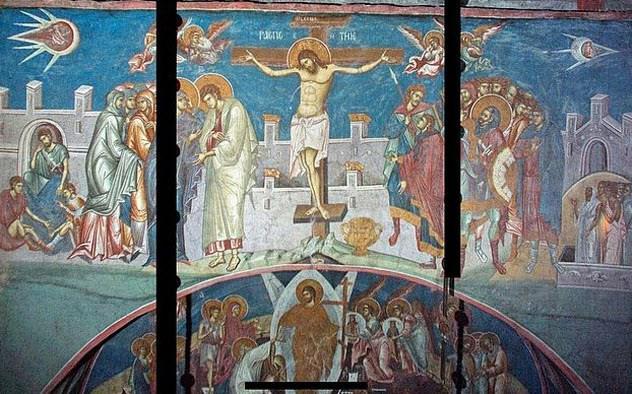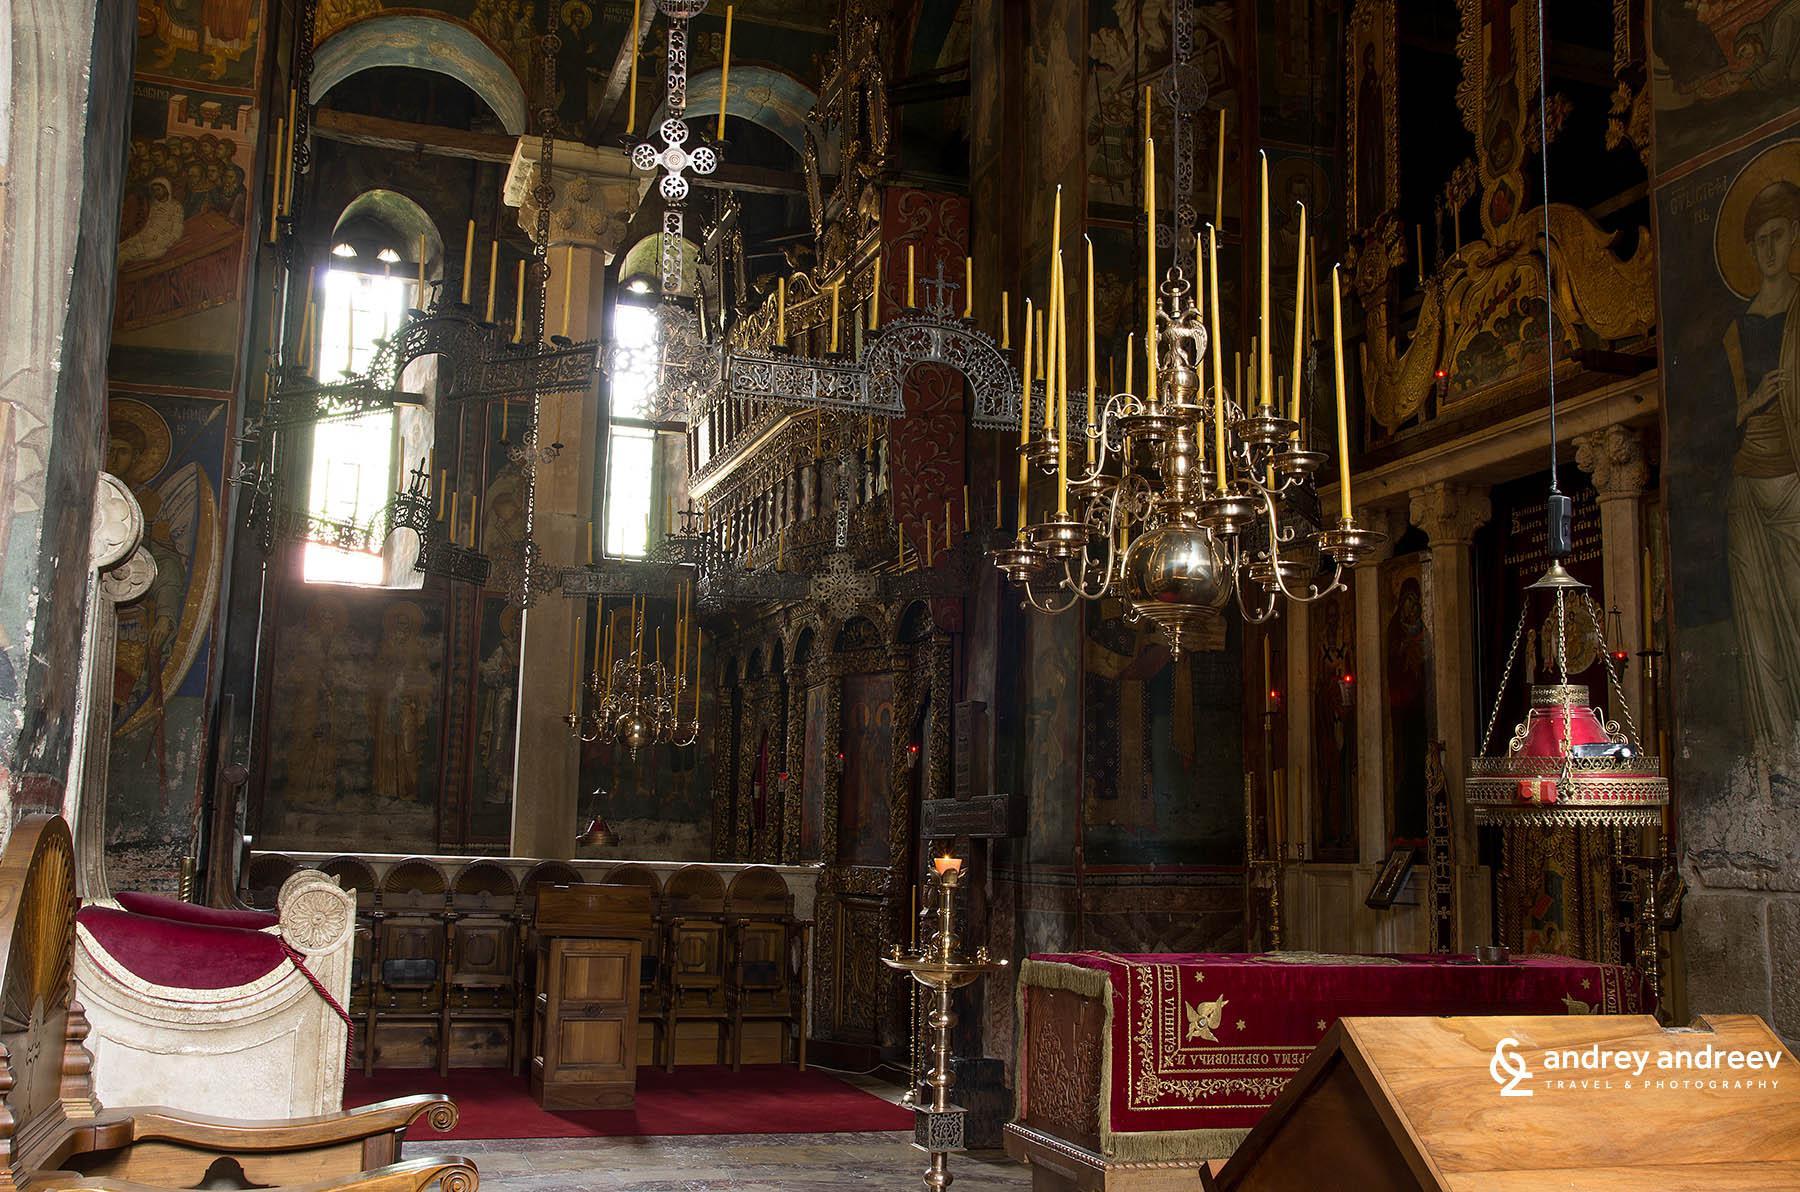The first image is the image on the left, the second image is the image on the right. Evaluate the accuracy of this statement regarding the images: "Clear arch-topped windows are featured in at least one image.". Is it true? Answer yes or no. Yes. The first image is the image on the left, the second image is the image on the right. For the images shown, is this caption "There is a person in the image on the left." true? Answer yes or no. No. 